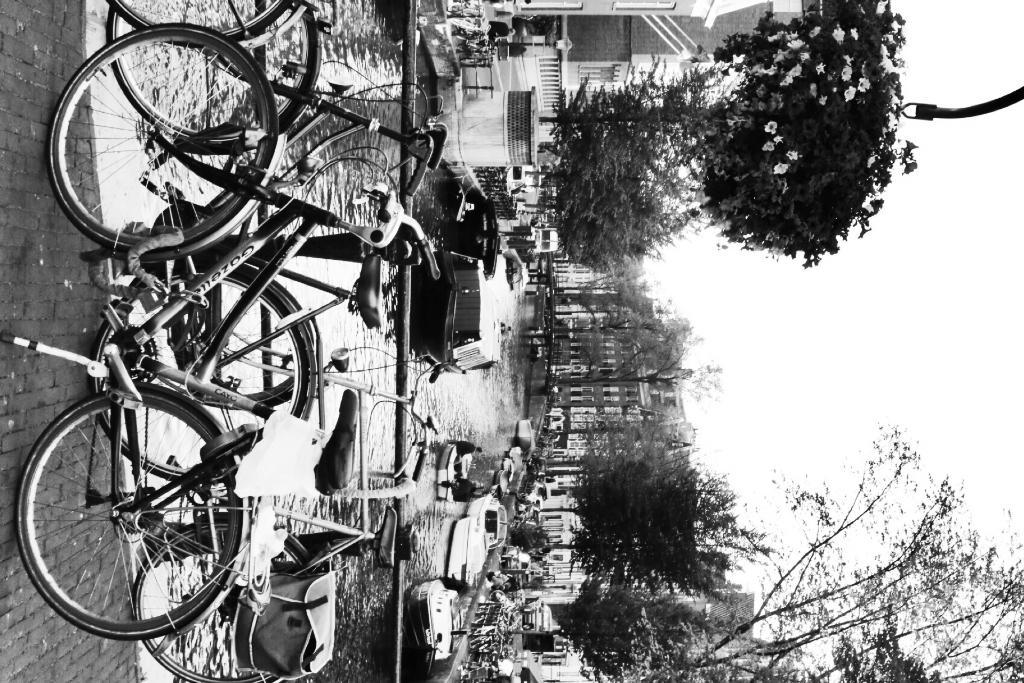What type of vehicles are present in the image? There are bicycles in the image. What body of water can be seen in the image? There is a canal in the image. What is on the canal in the image? There are boats on the canal. What type of vegetation is visible in the background of the image? There are trees in the background of the image. What type of screw can be seen holding the bicycle together in the image? There is no screw visible holding the bicycle together in the image. What type of stick is being used by the people in the boats in the image? There are no people or sticks visible in the boats in the image. 